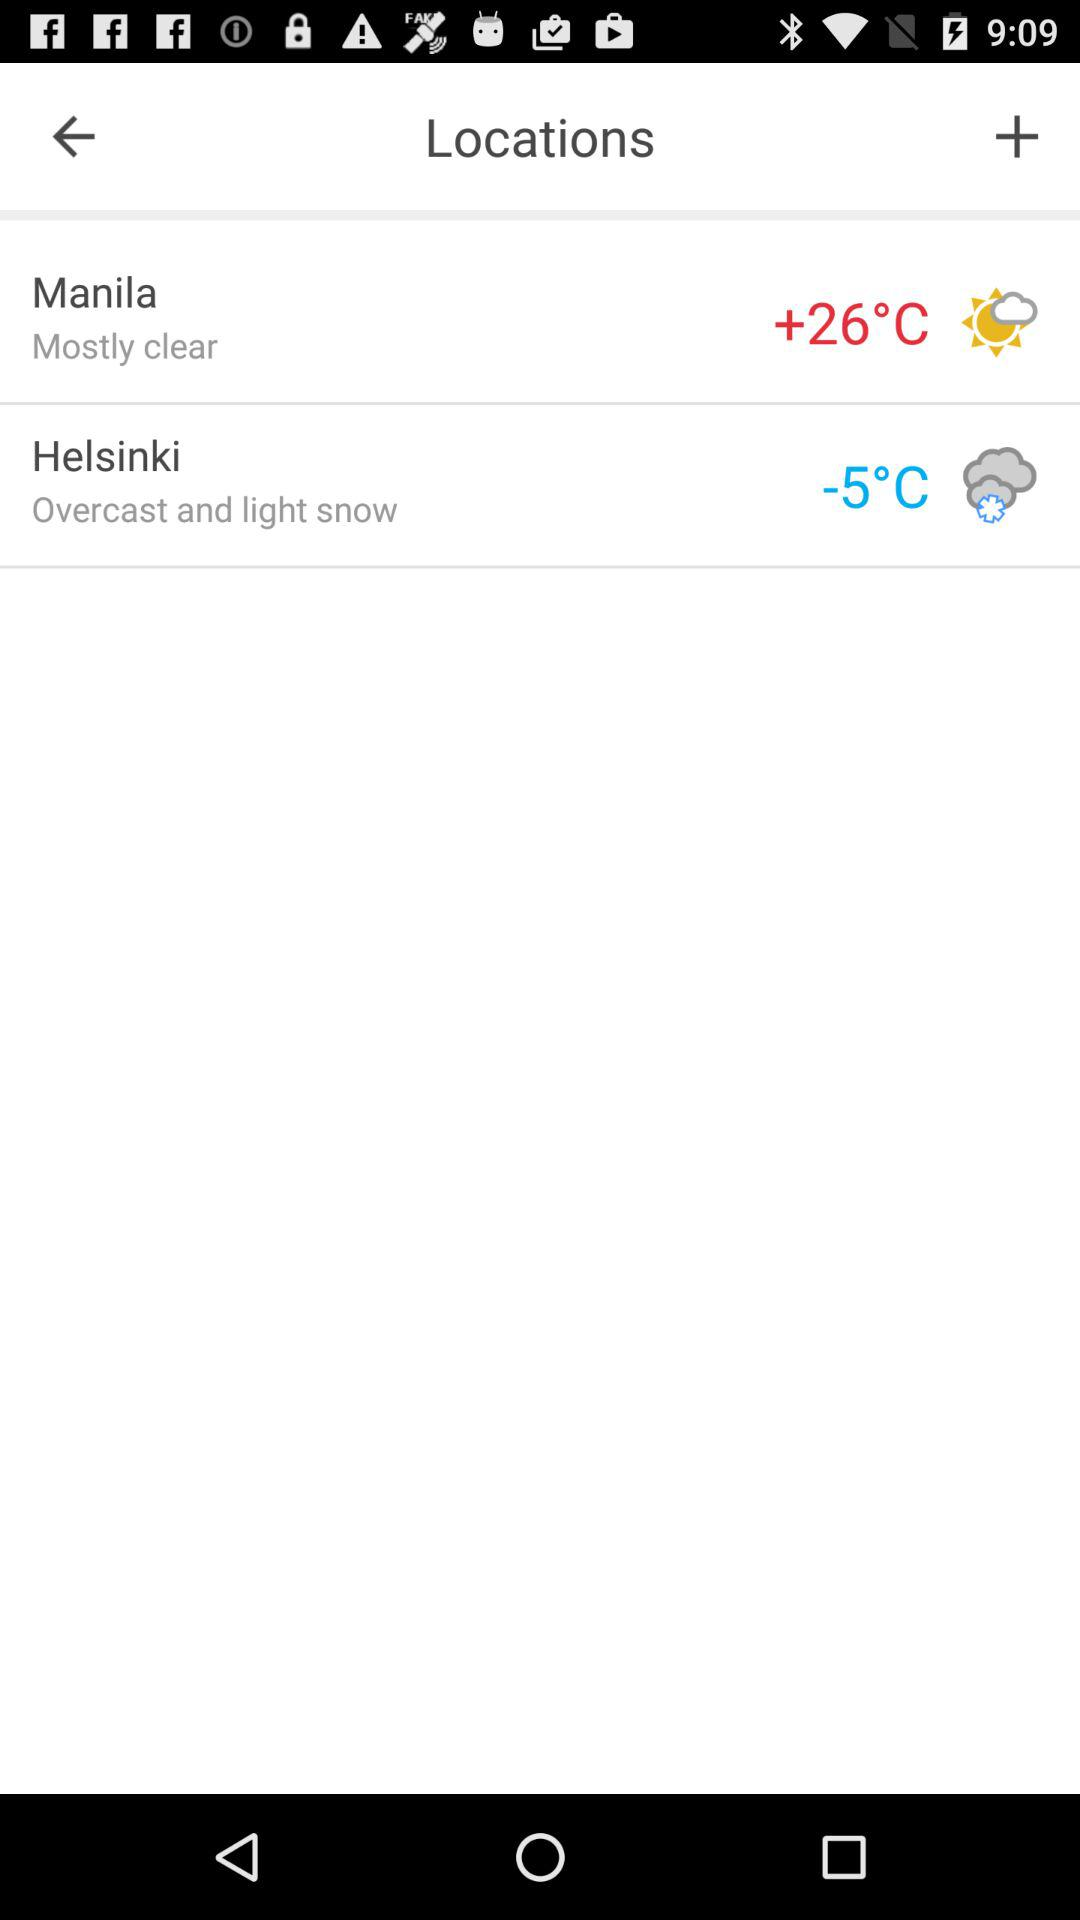What's the temperature in Manila? The temperature in Manila is +26 °C. 